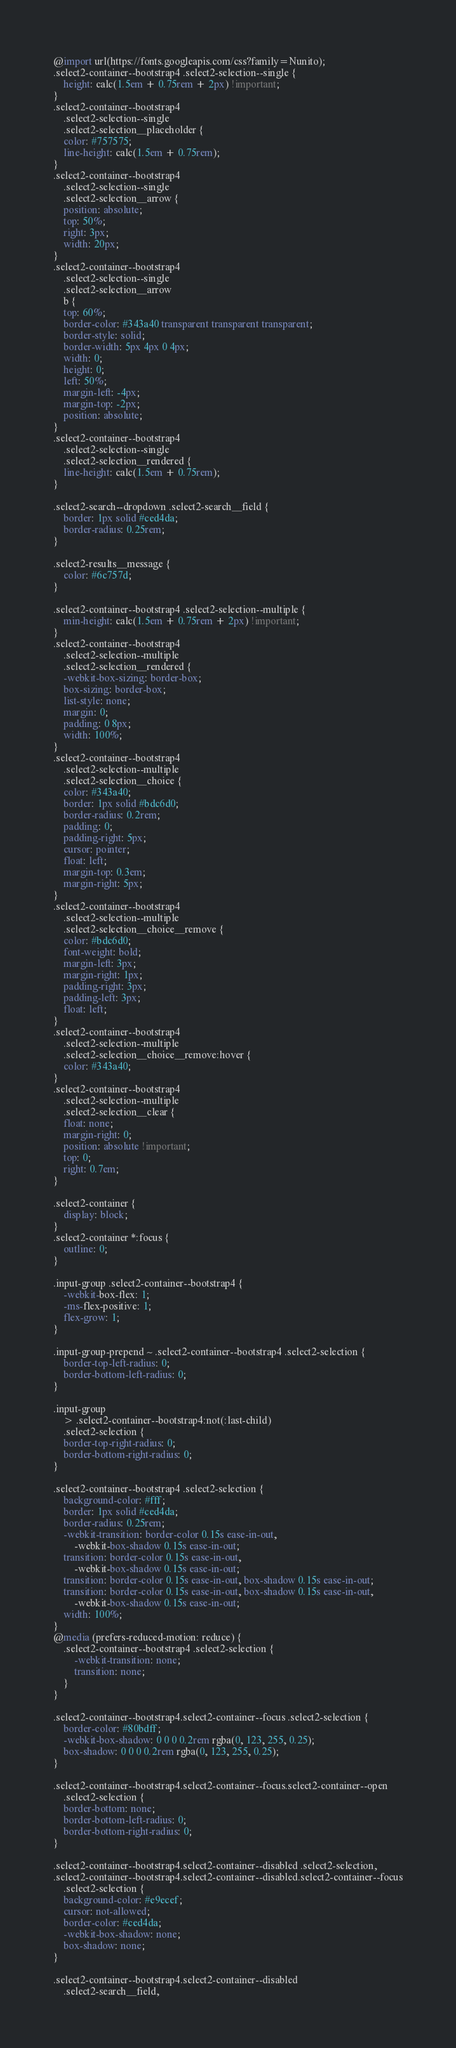Convert code to text. <code><loc_0><loc_0><loc_500><loc_500><_CSS_>@import url(https://fonts.googleapis.com/css?family=Nunito);
.select2-container--bootstrap4 .select2-selection--single {
    height: calc(1.5em + 0.75rem + 2px) !important;
}
.select2-container--bootstrap4
    .select2-selection--single
    .select2-selection__placeholder {
    color: #757575;
    line-height: calc(1.5em + 0.75rem);
}
.select2-container--bootstrap4
    .select2-selection--single
    .select2-selection__arrow {
    position: absolute;
    top: 50%;
    right: 3px;
    width: 20px;
}
.select2-container--bootstrap4
    .select2-selection--single
    .select2-selection__arrow
    b {
    top: 60%;
    border-color: #343a40 transparent transparent transparent;
    border-style: solid;
    border-width: 5px 4px 0 4px;
    width: 0;
    height: 0;
    left: 50%;
    margin-left: -4px;
    margin-top: -2px;
    position: absolute;
}
.select2-container--bootstrap4
    .select2-selection--single
    .select2-selection__rendered {
    line-height: calc(1.5em + 0.75rem);
}

.select2-search--dropdown .select2-search__field {
    border: 1px solid #ced4da;
    border-radius: 0.25rem;
}

.select2-results__message {
    color: #6c757d;
}

.select2-container--bootstrap4 .select2-selection--multiple {
    min-height: calc(1.5em + 0.75rem + 2px) !important;
}
.select2-container--bootstrap4
    .select2-selection--multiple
    .select2-selection__rendered {
    -webkit-box-sizing: border-box;
    box-sizing: border-box;
    list-style: none;
    margin: 0;
    padding: 0 8px;
    width: 100%;
}
.select2-container--bootstrap4
    .select2-selection--multiple
    .select2-selection__choice {
    color: #343a40;
    border: 1px solid #bdc6d0;
    border-radius: 0.2rem;
    padding: 0;
    padding-right: 5px;
    cursor: pointer;
    float: left;
    margin-top: 0.3em;
    margin-right: 5px;
}
.select2-container--bootstrap4
    .select2-selection--multiple
    .select2-selection__choice__remove {
    color: #bdc6d0;
    font-weight: bold;
    margin-left: 3px;
    margin-right: 1px;
    padding-right: 3px;
    padding-left: 3px;
    float: left;
}
.select2-container--bootstrap4
    .select2-selection--multiple
    .select2-selection__choice__remove:hover {
    color: #343a40;
}
.select2-container--bootstrap4
    .select2-selection--multiple
    .select2-selection__clear {
    float: none;
    margin-right: 0;
    position: absolute !important;
    top: 0;
    right: 0.7em;
}

.select2-container {
    display: block;
}
.select2-container *:focus {
    outline: 0;
}

.input-group .select2-container--bootstrap4 {
    -webkit-box-flex: 1;
    -ms-flex-positive: 1;
    flex-grow: 1;
}

.input-group-prepend ~ .select2-container--bootstrap4 .select2-selection {
    border-top-left-radius: 0;
    border-bottom-left-radius: 0;
}

.input-group
    > .select2-container--bootstrap4:not(:last-child)
    .select2-selection {
    border-top-right-radius: 0;
    border-bottom-right-radius: 0;
}

.select2-container--bootstrap4 .select2-selection {
    background-color: #fff;
    border: 1px solid #ced4da;
    border-radius: 0.25rem;
    -webkit-transition: border-color 0.15s ease-in-out,
        -webkit-box-shadow 0.15s ease-in-out;
    transition: border-color 0.15s ease-in-out,
        -webkit-box-shadow 0.15s ease-in-out;
    transition: border-color 0.15s ease-in-out, box-shadow 0.15s ease-in-out;
    transition: border-color 0.15s ease-in-out, box-shadow 0.15s ease-in-out,
        -webkit-box-shadow 0.15s ease-in-out;
    width: 100%;
}
@media (prefers-reduced-motion: reduce) {
    .select2-container--bootstrap4 .select2-selection {
        -webkit-transition: none;
        transition: none;
    }
}

.select2-container--bootstrap4.select2-container--focus .select2-selection {
    border-color: #80bdff;
    -webkit-box-shadow: 0 0 0 0.2rem rgba(0, 123, 255, 0.25);
    box-shadow: 0 0 0 0.2rem rgba(0, 123, 255, 0.25);
}

.select2-container--bootstrap4.select2-container--focus.select2-container--open
    .select2-selection {
    border-bottom: none;
    border-bottom-left-radius: 0;
    border-bottom-right-radius: 0;
}

.select2-container--bootstrap4.select2-container--disabled .select2-selection,
.select2-container--bootstrap4.select2-container--disabled.select2-container--focus
    .select2-selection {
    background-color: #e9ecef;
    cursor: not-allowed;
    border-color: #ced4da;
    -webkit-box-shadow: none;
    box-shadow: none;
}

.select2-container--bootstrap4.select2-container--disabled
    .select2-search__field,</code> 